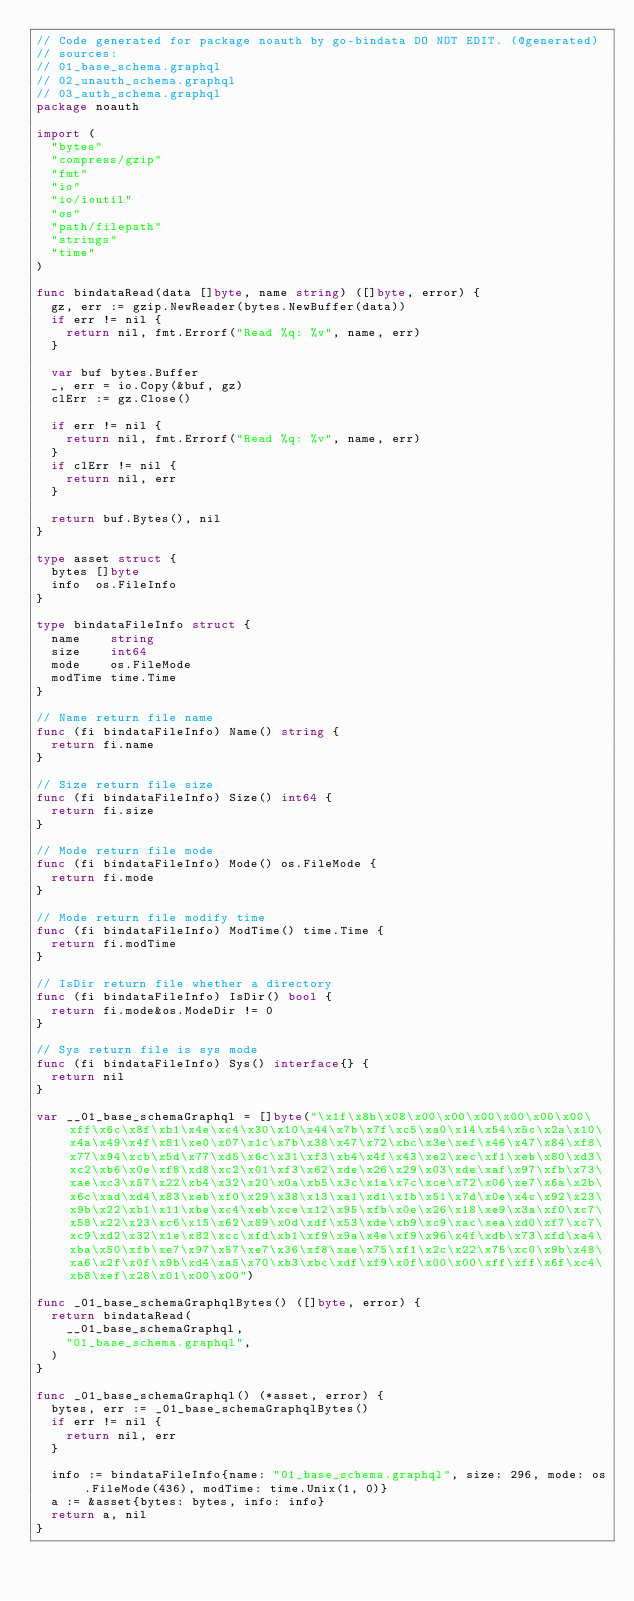<code> <loc_0><loc_0><loc_500><loc_500><_Go_>// Code generated for package noauth by go-bindata DO NOT EDIT. (@generated)
// sources:
// 01_base_schema.graphql
// 02_unauth_schema.graphql
// 03_auth_schema.graphql
package noauth

import (
	"bytes"
	"compress/gzip"
	"fmt"
	"io"
	"io/ioutil"
	"os"
	"path/filepath"
	"strings"
	"time"
)

func bindataRead(data []byte, name string) ([]byte, error) {
	gz, err := gzip.NewReader(bytes.NewBuffer(data))
	if err != nil {
		return nil, fmt.Errorf("Read %q: %v", name, err)
	}

	var buf bytes.Buffer
	_, err = io.Copy(&buf, gz)
	clErr := gz.Close()

	if err != nil {
		return nil, fmt.Errorf("Read %q: %v", name, err)
	}
	if clErr != nil {
		return nil, err
	}

	return buf.Bytes(), nil
}

type asset struct {
	bytes []byte
	info  os.FileInfo
}

type bindataFileInfo struct {
	name    string
	size    int64
	mode    os.FileMode
	modTime time.Time
}

// Name return file name
func (fi bindataFileInfo) Name() string {
	return fi.name
}

// Size return file size
func (fi bindataFileInfo) Size() int64 {
	return fi.size
}

// Mode return file mode
func (fi bindataFileInfo) Mode() os.FileMode {
	return fi.mode
}

// Mode return file modify time
func (fi bindataFileInfo) ModTime() time.Time {
	return fi.modTime
}

// IsDir return file whether a directory
func (fi bindataFileInfo) IsDir() bool {
	return fi.mode&os.ModeDir != 0
}

// Sys return file is sys mode
func (fi bindataFileInfo) Sys() interface{} {
	return nil
}

var __01_base_schemaGraphql = []byte("\x1f\x8b\x08\x00\x00\x00\x00\x00\x00\xff\x6c\x8f\xb1\x4e\xc4\x30\x10\x44\x7b\x7f\xc5\xa0\x14\x54\x5c\x2a\x10\x4a\x49\x4f\x81\xe0\x07\x1c\x7b\x38\x47\x72\xbc\x3e\xef\x46\x47\x84\xf8\x77\x94\xcb\x5d\x77\xd5\x6c\x31\xf3\xb4\x4f\x43\xe2\xec\xf1\xeb\x80\xd3\xc2\xb6\x0e\xf8\xd8\xc2\x01\xf3\x62\xde\x26\x29\x03\xde\xaf\x97\xfb\x73\xae\xc3\x57\x22\xb4\x32\x20\x0a\xb5\x3c\x1a\x7c\xce\x72\x06\xe7\x6a\x2b\x6c\xad\xd4\x83\xeb\xf0\x29\x38\x13\xa1\xd1\x1b\x51\x7d\x0e\x4c\x92\x23\x9b\x22\xb1\x11\xbe\xc4\xeb\xce\x12\x95\xfb\x0e\x26\x18\xe9\x3a\xf0\xc7\x58\x22\x23\xc6\x15\x62\x89\x0d\xdf\x53\xde\xb9\xc9\xac\xea\xd0\xf7\xc7\xc9\xd2\x32\x1e\x82\xcc\xfd\xb1\xf9\x9a\x4e\xf9\x96\x4f\xdb\x73\xfd\xa4\xba\x50\xfb\xe7\x97\x57\xe7\x36\xf8\xae\x75\xf1\x2c\x22\x75\xc0\x9b\x48\xa6\x2f\x0f\x9b\xd4\xa5\x70\xb3\xbc\xdf\xf9\x0f\x00\x00\xff\xff\x6f\xc4\xb8\xef\x28\x01\x00\x00")

func _01_base_schemaGraphqlBytes() ([]byte, error) {
	return bindataRead(
		__01_base_schemaGraphql,
		"01_base_schema.graphql",
	)
}

func _01_base_schemaGraphql() (*asset, error) {
	bytes, err := _01_base_schemaGraphqlBytes()
	if err != nil {
		return nil, err
	}

	info := bindataFileInfo{name: "01_base_schema.graphql", size: 296, mode: os.FileMode(436), modTime: time.Unix(1, 0)}
	a := &asset{bytes: bytes, info: info}
	return a, nil
}
</code> 